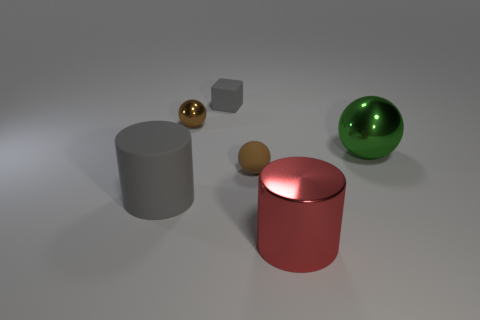Add 1 cyan matte cubes. How many objects exist? 7 Subtract all cylinders. How many objects are left? 4 Subtract 1 gray cylinders. How many objects are left? 5 Subtract all big rubber objects. Subtract all cylinders. How many objects are left? 3 Add 5 big cylinders. How many big cylinders are left? 7 Add 6 red cylinders. How many red cylinders exist? 7 